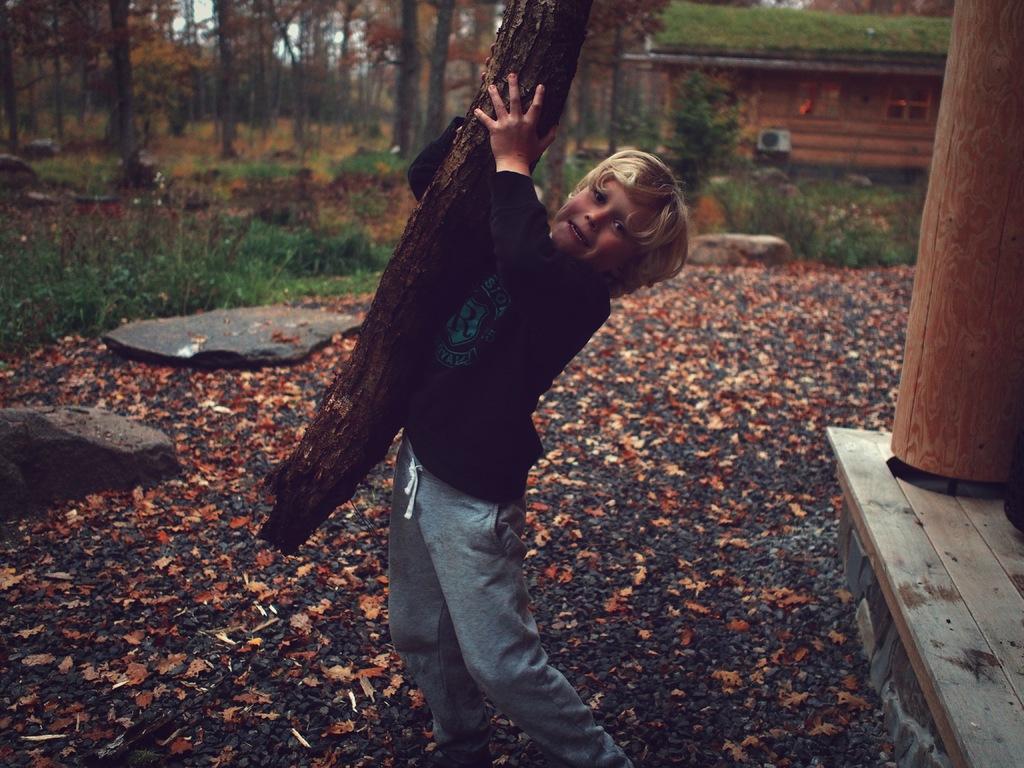Describe this image in one or two sentences. In this image I can see a person standing and holding some wooden object and the person is wearing black shirt and blue pant, background I can see a wooden house, trees in green color and the sky is in white color. 